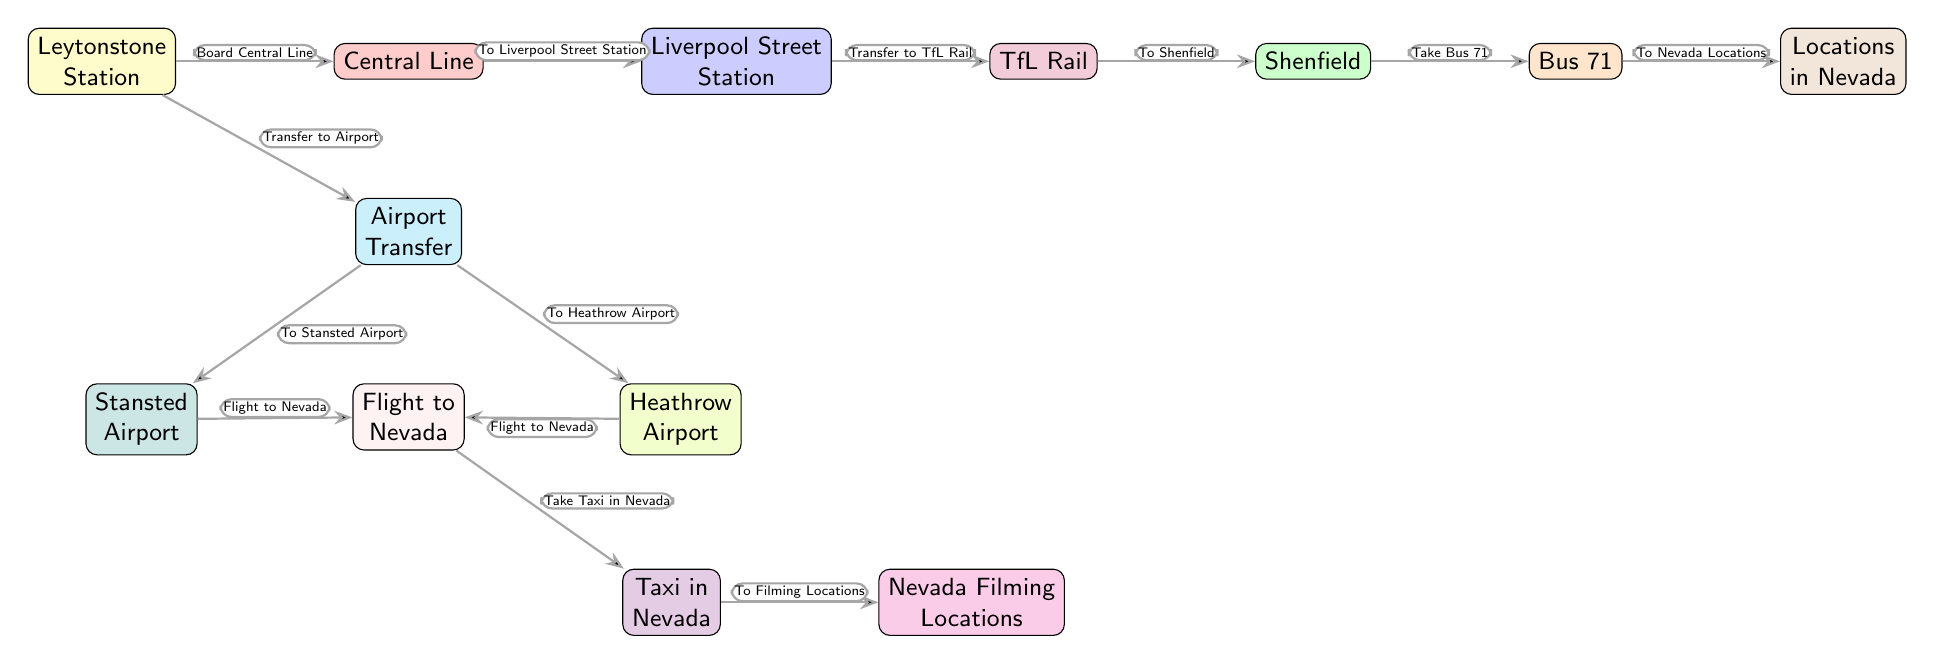What is the first step to travel from Leytonstone to filming locations? The first step is to board the Central Line at Leytonstone Station, as indicated by the edge labeled "Board Central Line."
Answer: Board Central Line How many different types of public transportation are shown in the diagram? The diagram illustrates four types of transportation: Central Line, TfL Rail, Bus 71, and flights to Nevada.
Answer: Four What is the destination of Bus 71? The destination of Bus 71 is the Nevada locations, as denoted by the edge labeled "To Nevada Locations."
Answer: Nevada Locations Which airport can you transfer to from Leytonstone Station? You can transfer to both Stansted Airport and Heathrow Airport from the Airport Transfer node.
Answer: Stansted Airport, Heathrow Airport What mode of transport is used to get from Shenfield to Nevada locations? The mode of transport used is Bus 71, as shown by the edge labeled "Take Bus 71."
Answer: Bus 71 What additional service is connected to the flights heading to Nevada? The additional service is a taxi in Nevada, which you take after the flights, as noted in the edge labeled "Take Taxi in Nevada."
Answer: Taxi in Nevada How many edges are present in the diagram? There are twelve edges that represent the connections between various nodes in the diagram.
Answer: Twelve What must you do after arriving at Liverpool Street Station? After arriving at Liverpool Street Station, you must transfer to TfL Rail, as indicated by the edge labeled "Transfer to TfL Rail."
Answer: Transfer to TfL Rail What does the final node represent in terms of the production process? The final node represents the Nevada filming locations, as indicated by the label in the node.
Answer: Nevada Filming Locations 